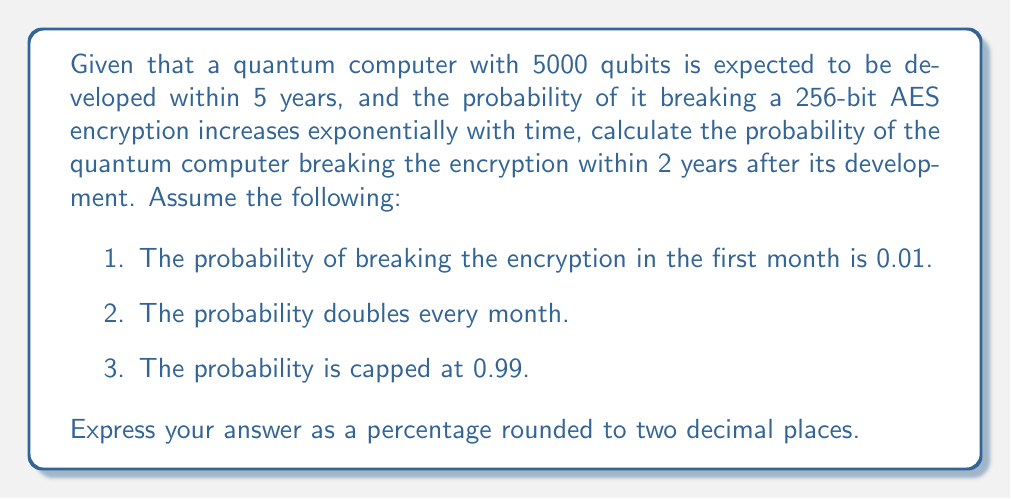Can you answer this question? Let's approach this step-by-step:

1) First, we need to calculate how many months are in 2 years:
   $2 \text{ years} \times 12 \text{ months/year} = 24 \text{ months}$

2) Now, let's set up our probability function. If $p(t)$ is the probability of breaking the encryption in month $t$, then:

   $p(t) = \min(0.01 \times 2^{t-1}, 0.99)$

3) To find the probability of breaking the encryption within 24 months, we need to calculate the probability of not breaking it in any of these months and subtract from 1:

   $P(\text{breaking within 24 months}) = 1 - P(\text{not breaking for 24 months})$

4) The probability of not breaking for 24 months is the product of the probabilities of not breaking in each individual month:

   $P(\text{not breaking for 24 months}) = \prod_{t=1}^{24} (1 - p(t))$

5) Let's calculate this product:

   For $t = 1$ to $11$: $p(t) = 0.01 \times 2^{t-1}$
   For $t \geq 12$: $p(t) = 0.99$ (capped)

   $\prod_{t=1}^{24} (1 - p(t)) = (1-0.01) \times (1-0.02) \times ... \times (1-0.99)^{13}$

6) Calculating this:

   $\prod_{t=1}^{24} (1 - p(t)) \approx 1.3675 \times 10^{-28}$

7) Therefore, the probability of breaking within 24 months is:

   $P(\text{breaking within 24 months}) = 1 - 1.3675 \times 10^{-28} \approx 0.9999999999999999999999999999$

8) Converting to a percentage and rounding to two decimal places:

   $0.9999999999999999999999999999 \times 100\% \approx 100.00\%$
Answer: 100.00% 